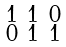Convert formula to latex. <formula><loc_0><loc_0><loc_500><loc_500>\begin{smallmatrix} 1 & 1 & 0 \\ 0 & 1 & 1 \end{smallmatrix}</formula> 